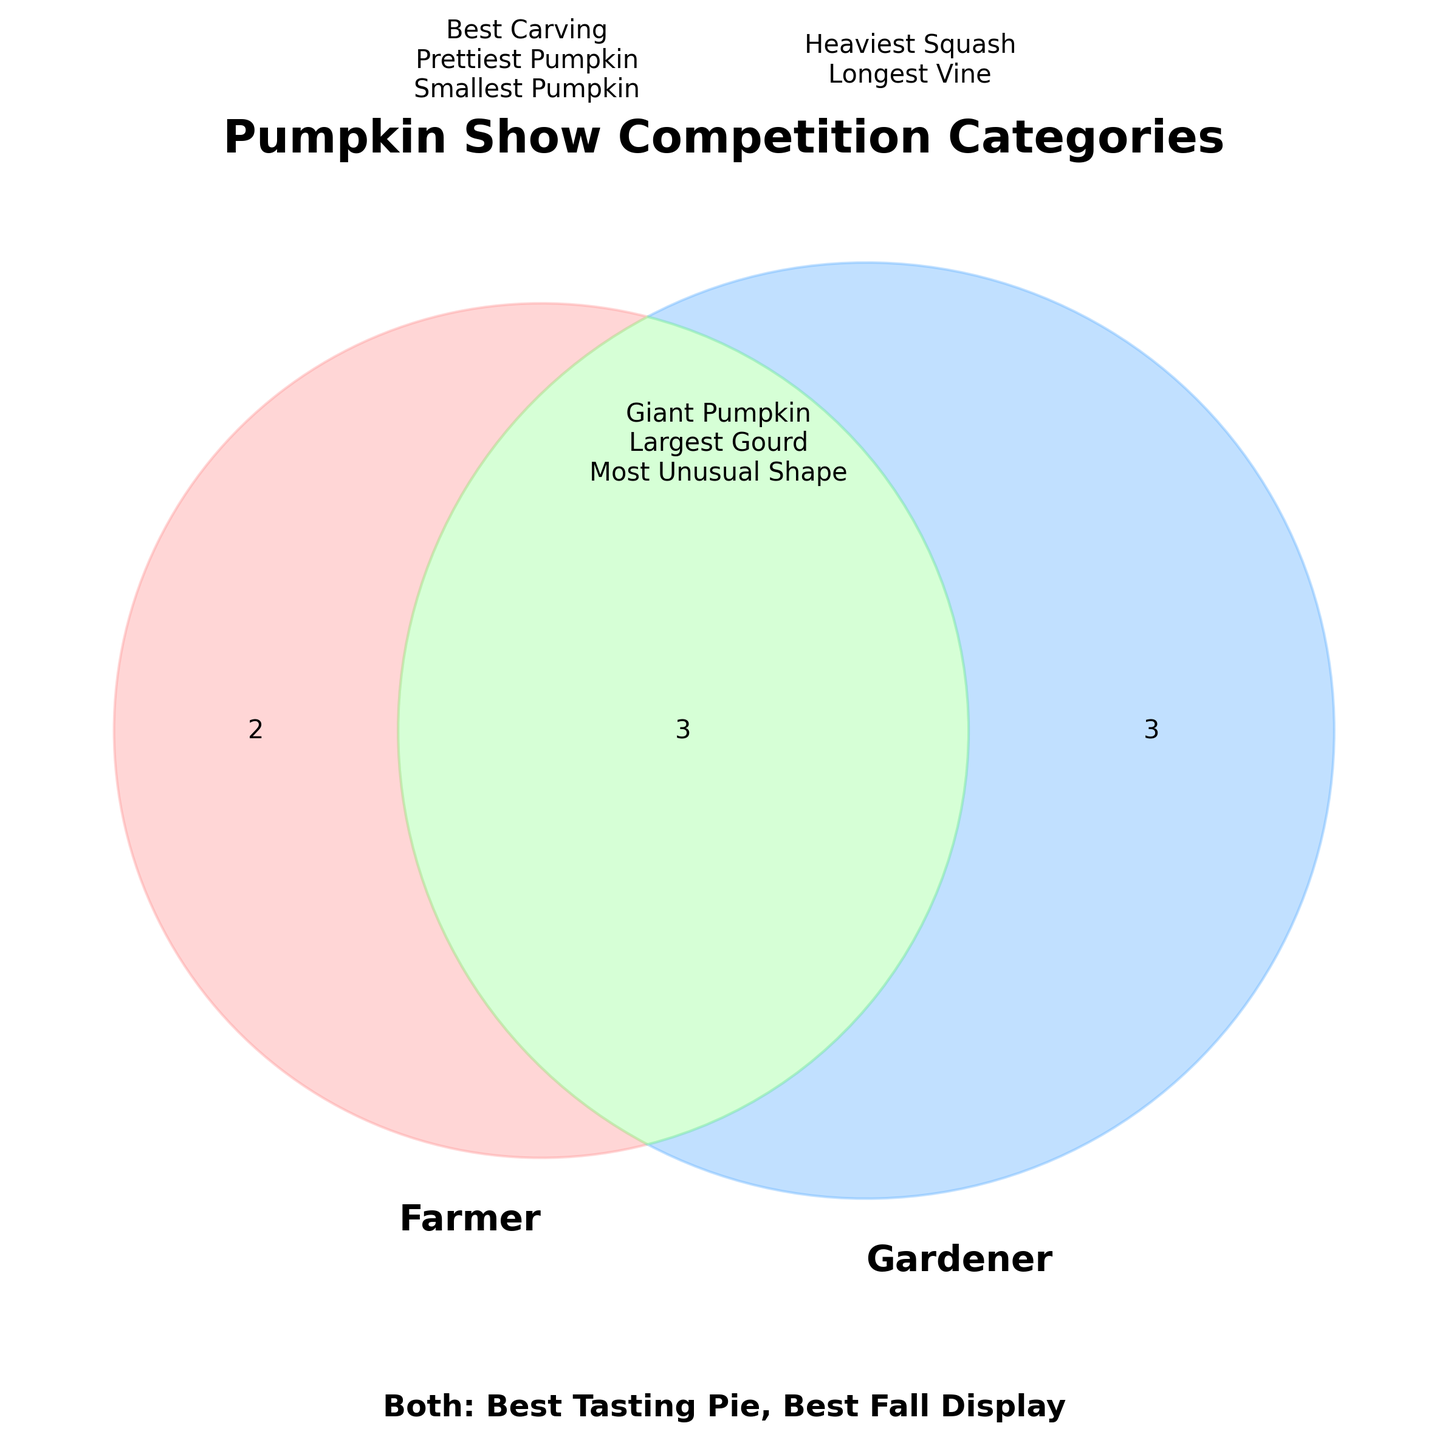What is the title of the diagram? The title is written at the top of the diagram. It reads "Pumpkin Show Competition Categories".
Answer: Pumpkin Show Competition Categories Which color represents the Farmer's unique categories? The Farmer’s unique categories can be found in the left part of the Venn diagram, which is colored in a light pink shade.
Answer: light pink Which competition category is shared by both the Farmer and the Gardener but not exclusive to either? By looking at the intersection of both circles in the Venn diagram (the part colored in light green), we can find shared categories.
Answer: Giant Pumpkin, Largest Gourd, Most Unusual Shape How many unique competition categories does the Gardener have? Examining the right part of the Venn diagram (light blue shade), we see the Gardener's unique categories listed. Count these categories.
Answer: 4 What are all the categories that the Farmer participates in? To answer this, combine the unique categories in the Farmer’s section and the shared categories in the intersection of both circles.
Answer: Heaviest Squash, Longest Vine, Giant Pumpkin, Largest Gourd, Most Unusual Shape What are the categories that neither the Farmer nor the Gardener participates in? Based on the data shown, the categories neither participate in aren't listed in any section of the Venn diagram (e.g., non-participating categories include "Best Tasting Pie" and "Best Fall Display" which appear elsewhere in the diagram's footer text).
Answer: Best Tasting Pie, Best Fall Display Which category appears only in the Gardener's section and not anywhere else? By inspecting the light blue section of the Venn diagram carefully, “Best Carving” is only shown in the Gardener's section and not shared or in Farmer's unique section.
Answer: Best Carving How many categories do both the Farmer and Gardener share, excluding any additional categories? Look at the intersection of the Venn diagram (highlighted in light green) to count the shared categories.
Answer: 3 